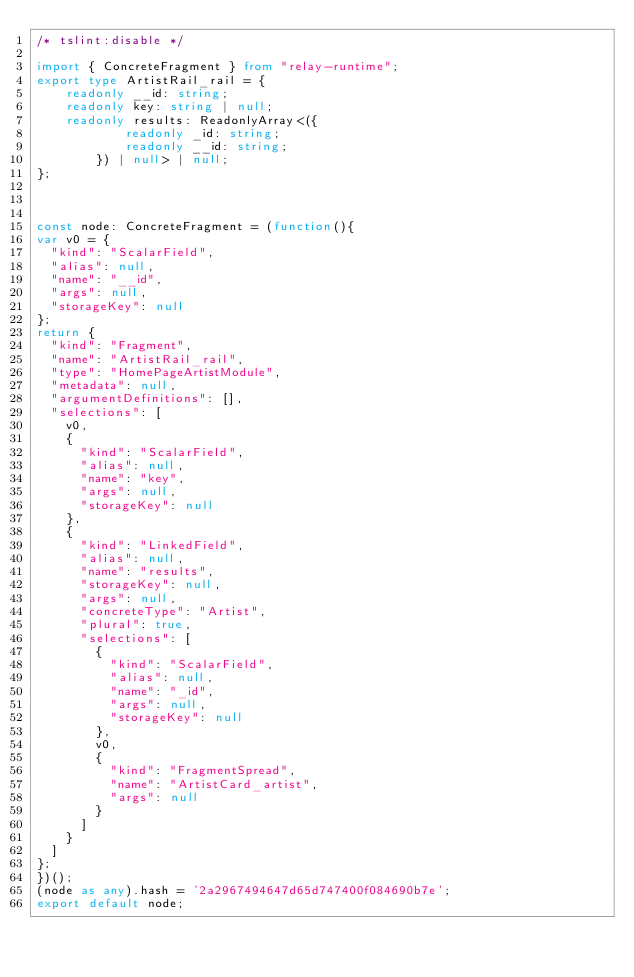<code> <loc_0><loc_0><loc_500><loc_500><_TypeScript_>/* tslint:disable */

import { ConcreteFragment } from "relay-runtime";
export type ArtistRail_rail = {
    readonly __id: string;
    readonly key: string | null;
    readonly results: ReadonlyArray<({
            readonly _id: string;
            readonly __id: string;
        }) | null> | null;
};



const node: ConcreteFragment = (function(){
var v0 = {
  "kind": "ScalarField",
  "alias": null,
  "name": "__id",
  "args": null,
  "storageKey": null
};
return {
  "kind": "Fragment",
  "name": "ArtistRail_rail",
  "type": "HomePageArtistModule",
  "metadata": null,
  "argumentDefinitions": [],
  "selections": [
    v0,
    {
      "kind": "ScalarField",
      "alias": null,
      "name": "key",
      "args": null,
      "storageKey": null
    },
    {
      "kind": "LinkedField",
      "alias": null,
      "name": "results",
      "storageKey": null,
      "args": null,
      "concreteType": "Artist",
      "plural": true,
      "selections": [
        {
          "kind": "ScalarField",
          "alias": null,
          "name": "_id",
          "args": null,
          "storageKey": null
        },
        v0,
        {
          "kind": "FragmentSpread",
          "name": "ArtistCard_artist",
          "args": null
        }
      ]
    }
  ]
};
})();
(node as any).hash = '2a2967494647d65d747400f084690b7e';
export default node;
</code> 